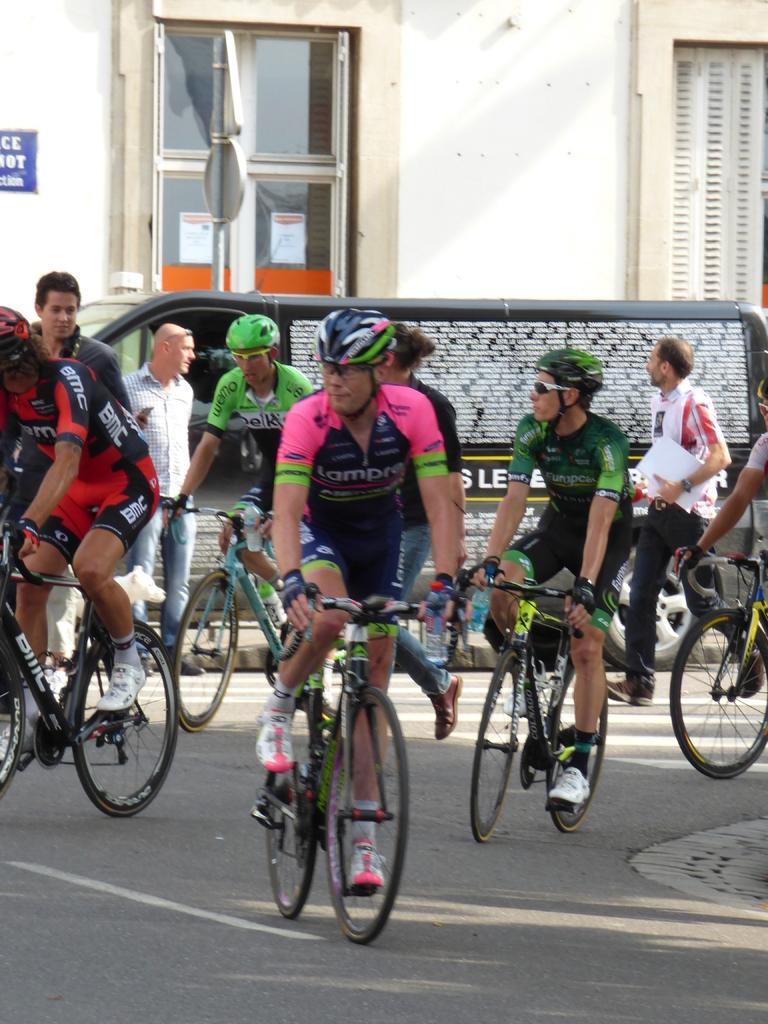Can you describe this image briefly? In this image there are few persons riding on bicycle, there are two persons visible on the road, behind them there is a vehicle, pole, wall of the building, window visible. 